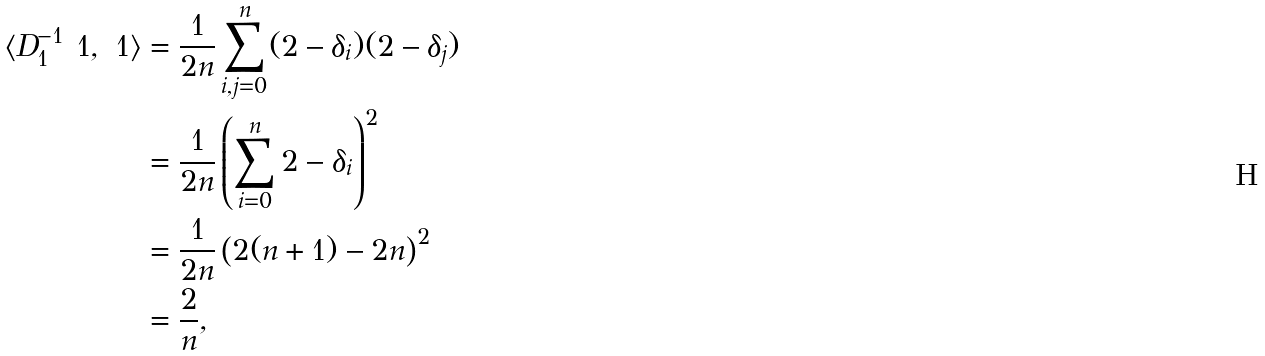<formula> <loc_0><loc_0><loc_500><loc_500>\langle D _ { 1 } ^ { - 1 } \ 1 , \ 1 \rangle & = \frac { 1 } { 2 n } \sum _ { i , j = 0 } ^ { n } ( 2 - \delta _ { i } ) ( 2 - \delta _ { j } ) \\ & = \frac { 1 } { 2 n } \left ( \sum _ { i = 0 } ^ { n } 2 - \delta _ { i } \right ) ^ { 2 } \\ & = \frac { 1 } { 2 n } \left ( 2 ( n + 1 ) - 2 n \right ) ^ { 2 } \\ & = \frac { 2 } { n } ,</formula> 